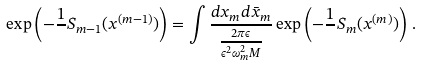<formula> <loc_0><loc_0><loc_500><loc_500>\exp \left ( - { \frac { 1 } { } } S _ { m - 1 } ( x ^ { ( m - 1 ) } ) \right ) = \int { \frac { d x _ { m } d \bar { x } _ { m } } { { \frac { 2 \pi \epsilon } { \epsilon ^ { 2 } \omega _ { m } ^ { 2 } M } } } } \exp \left ( - \frac { 1 } { } S _ { m } ( x ^ { ( m ) } ) \right ) \, .</formula> 